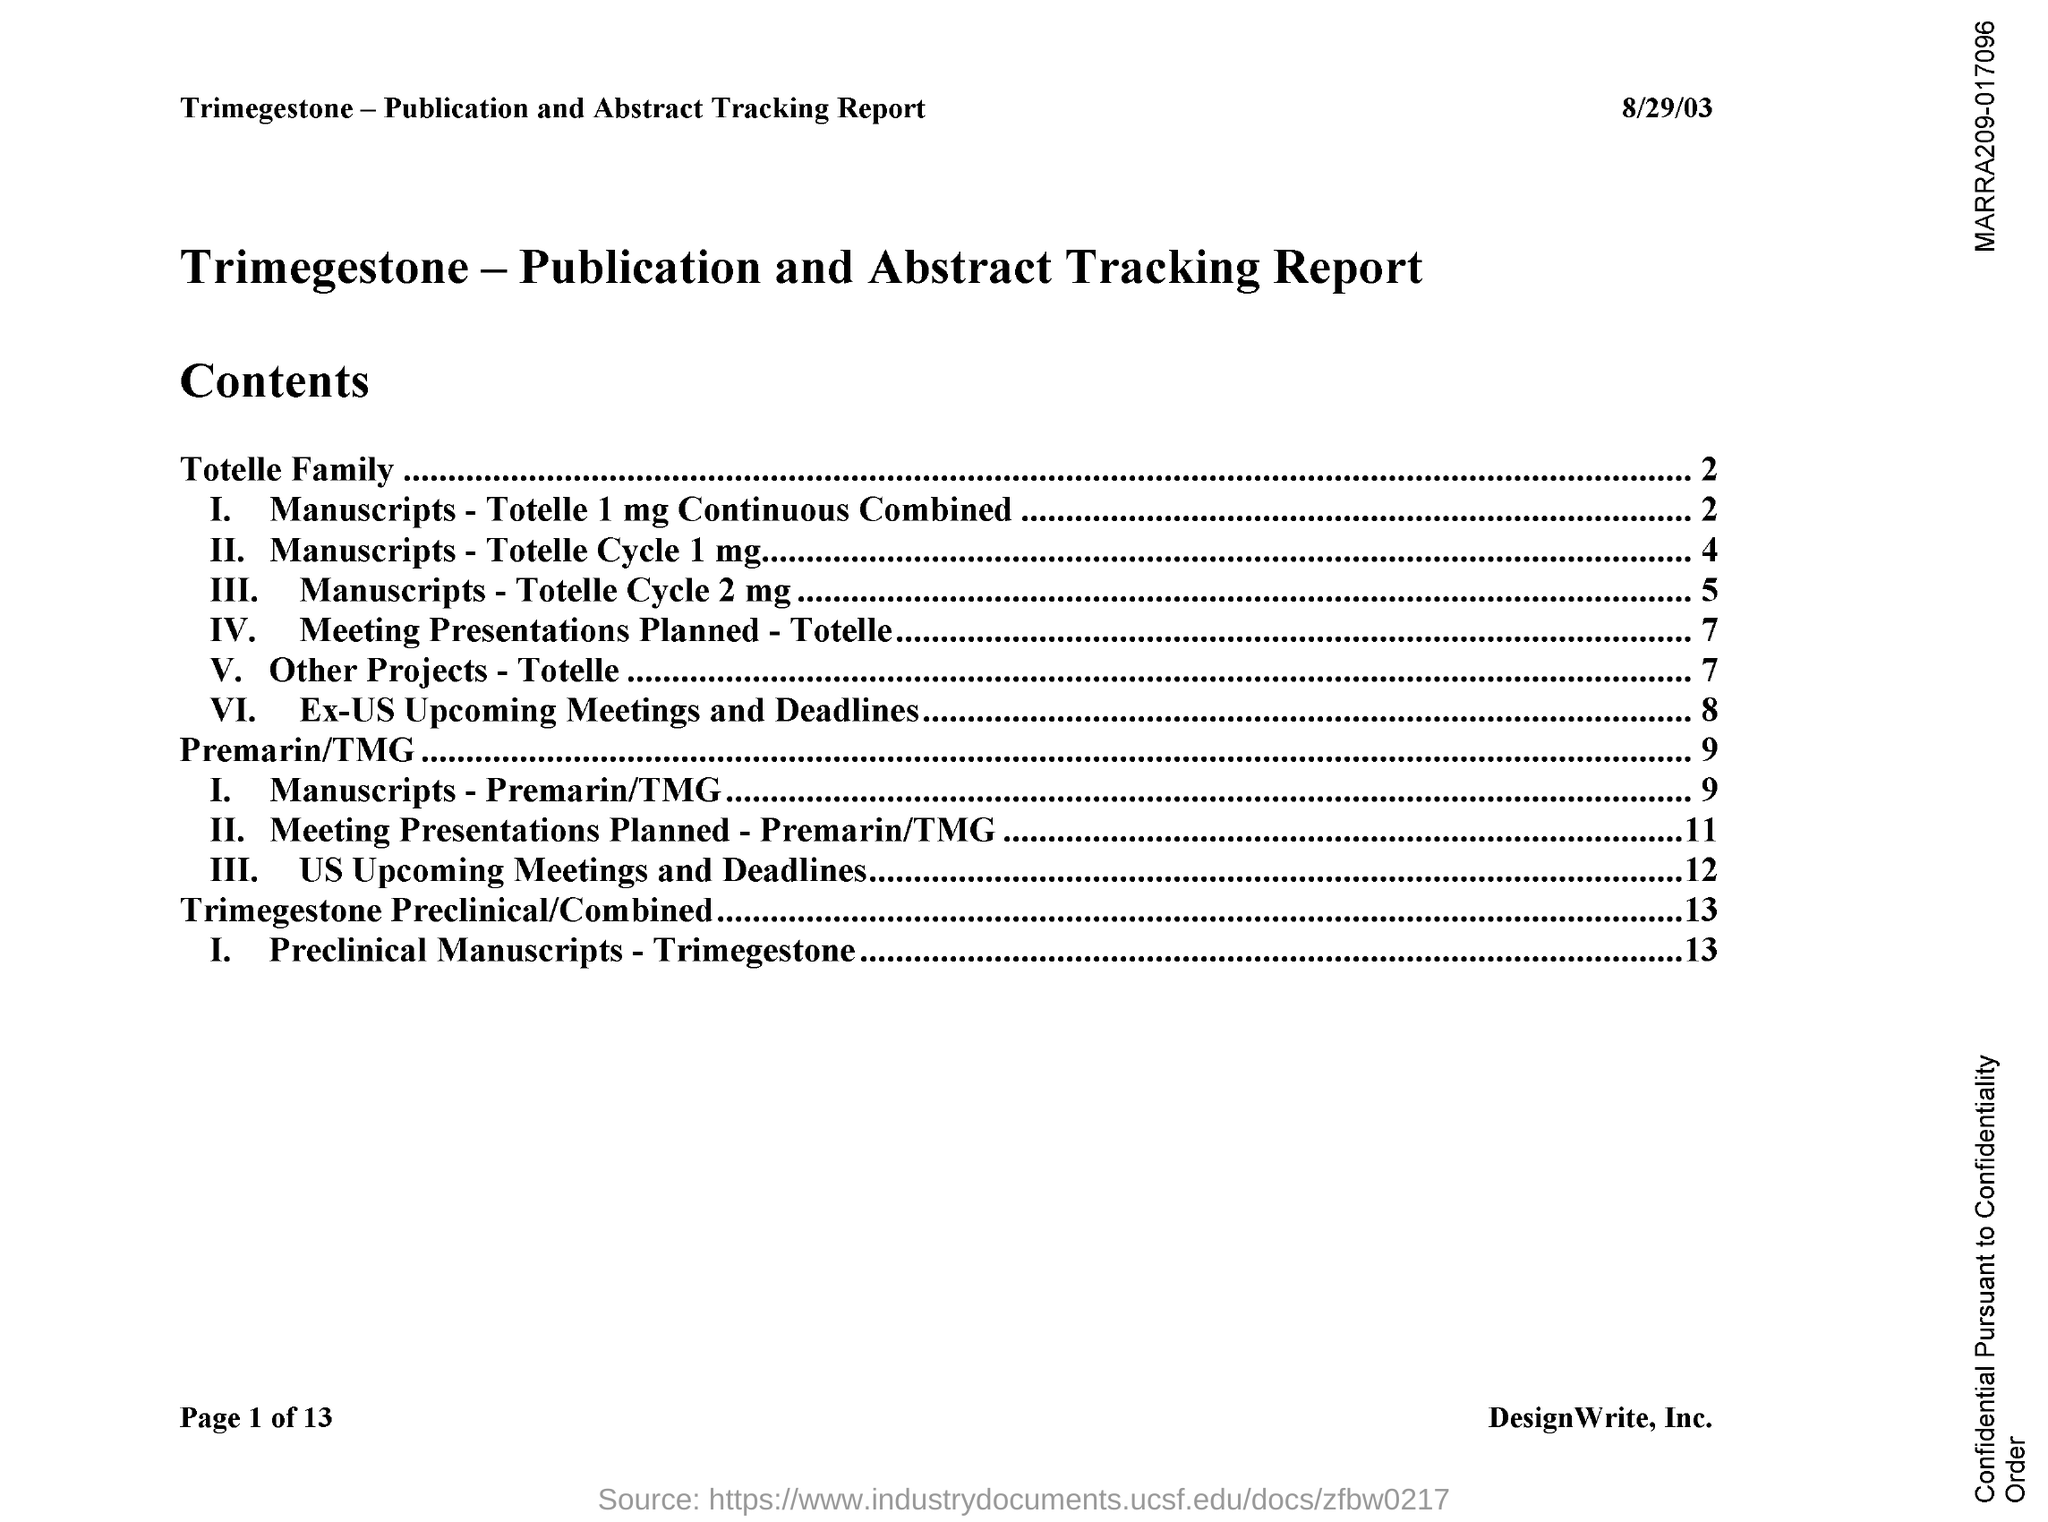Specify some key components in this picture. The date mentioned in the document is August 29, 2003. 